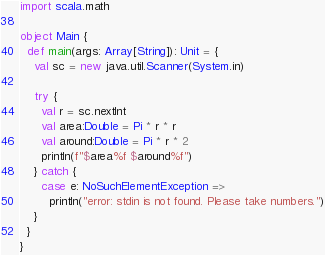<code> <loc_0><loc_0><loc_500><loc_500><_Scala_>import scala.math

object Main {
  def main(args: Array[String]): Unit = {
    val sc = new java.util.Scanner(System.in)

    try {
      val r = sc.nextInt
      val area:Double = Pi * r * r
      val around:Double = Pi * r * 2
      println(f"$area%f $around%f")
    } catch {
      case e: NoSuchElementException =>
        println("error: stdin is not found. Please take numbers.")
    }
  }
}</code> 